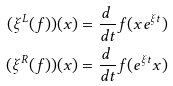<formula> <loc_0><loc_0><loc_500><loc_500>( \xi ^ { L } ( f ) ) ( x ) & = \frac { d \ } { d t } f ( x e ^ { \xi t } ) \\ ( \xi ^ { R } ( f ) ) ( x ) & = \frac { d \ } { d t } f ( e ^ { \xi t } x )</formula> 